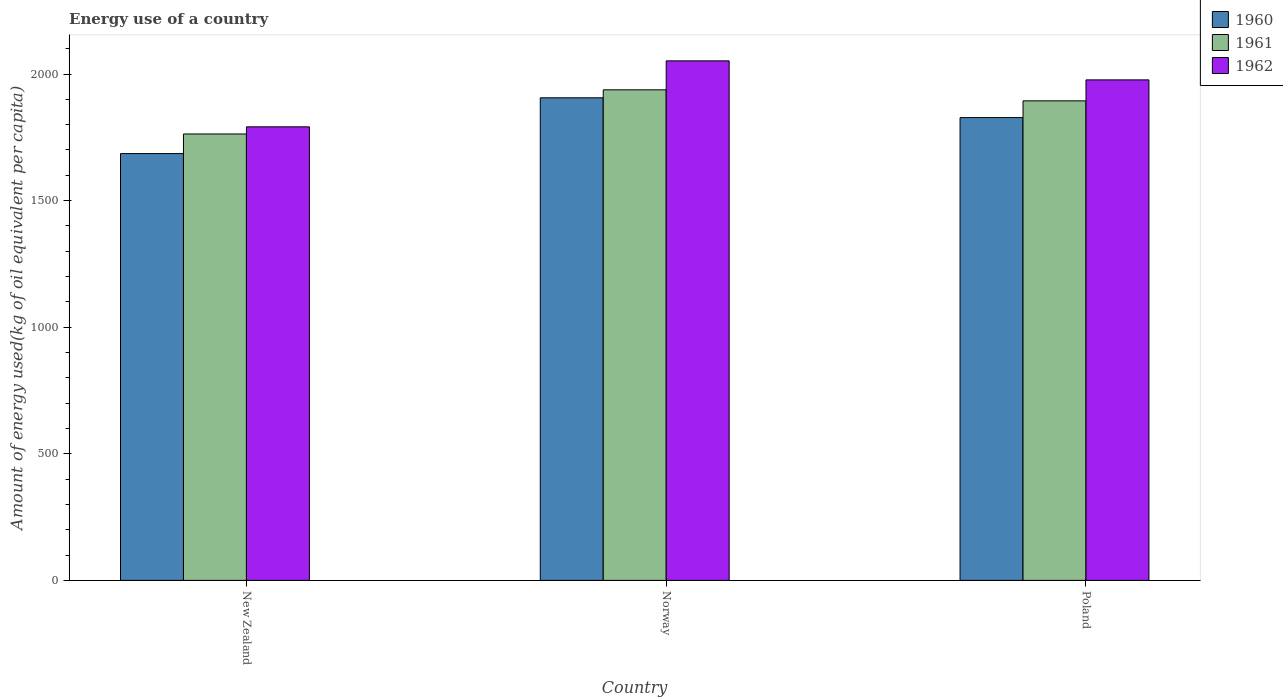How many different coloured bars are there?
Your answer should be compact. 3. Are the number of bars per tick equal to the number of legend labels?
Give a very brief answer. Yes. How many bars are there on the 3rd tick from the left?
Provide a short and direct response. 3. How many bars are there on the 3rd tick from the right?
Offer a very short reply. 3. What is the label of the 3rd group of bars from the left?
Ensure brevity in your answer.  Poland. In how many cases, is the number of bars for a given country not equal to the number of legend labels?
Make the answer very short. 0. What is the amount of energy used in in 1961 in Norway?
Provide a succinct answer. 1937.64. Across all countries, what is the maximum amount of energy used in in 1960?
Your answer should be compact. 1906.17. Across all countries, what is the minimum amount of energy used in in 1960?
Your response must be concise. 1685.79. In which country was the amount of energy used in in 1962 maximum?
Your answer should be compact. Norway. In which country was the amount of energy used in in 1962 minimum?
Offer a terse response. New Zealand. What is the total amount of energy used in in 1960 in the graph?
Offer a very short reply. 5419.9. What is the difference between the amount of energy used in in 1960 in Norway and that in Poland?
Provide a short and direct response. 78.24. What is the difference between the amount of energy used in in 1961 in Norway and the amount of energy used in in 1960 in New Zealand?
Provide a short and direct response. 251.86. What is the average amount of energy used in in 1960 per country?
Ensure brevity in your answer.  1806.63. What is the difference between the amount of energy used in of/in 1962 and amount of energy used in of/in 1961 in Norway?
Your answer should be very brief. 114.41. In how many countries, is the amount of energy used in in 1962 greater than 300 kg?
Your answer should be compact. 3. What is the ratio of the amount of energy used in in 1961 in New Zealand to that in Poland?
Offer a very short reply. 0.93. Is the amount of energy used in in 1962 in New Zealand less than that in Poland?
Ensure brevity in your answer.  Yes. What is the difference between the highest and the second highest amount of energy used in in 1962?
Offer a terse response. -75.19. What is the difference between the highest and the lowest amount of energy used in in 1962?
Give a very brief answer. 260.59. In how many countries, is the amount of energy used in in 1960 greater than the average amount of energy used in in 1960 taken over all countries?
Provide a short and direct response. 2. Is the sum of the amount of energy used in in 1961 in New Zealand and Poland greater than the maximum amount of energy used in in 1960 across all countries?
Provide a short and direct response. Yes. What does the 2nd bar from the right in Poland represents?
Give a very brief answer. 1961. Is it the case that in every country, the sum of the amount of energy used in in 1962 and amount of energy used in in 1960 is greater than the amount of energy used in in 1961?
Provide a succinct answer. Yes. How many bars are there?
Keep it short and to the point. 9. Are the values on the major ticks of Y-axis written in scientific E-notation?
Provide a succinct answer. No. Does the graph contain grids?
Ensure brevity in your answer.  No. How are the legend labels stacked?
Your response must be concise. Vertical. What is the title of the graph?
Provide a short and direct response. Energy use of a country. Does "1992" appear as one of the legend labels in the graph?
Provide a short and direct response. No. What is the label or title of the Y-axis?
Your answer should be compact. Amount of energy used(kg of oil equivalent per capita). What is the Amount of energy used(kg of oil equivalent per capita) of 1960 in New Zealand?
Offer a very short reply. 1685.79. What is the Amount of energy used(kg of oil equivalent per capita) of 1961 in New Zealand?
Your answer should be very brief. 1763.26. What is the Amount of energy used(kg of oil equivalent per capita) of 1962 in New Zealand?
Provide a short and direct response. 1791.46. What is the Amount of energy used(kg of oil equivalent per capita) of 1960 in Norway?
Ensure brevity in your answer.  1906.17. What is the Amount of energy used(kg of oil equivalent per capita) of 1961 in Norway?
Make the answer very short. 1937.64. What is the Amount of energy used(kg of oil equivalent per capita) of 1962 in Norway?
Make the answer very short. 2052.05. What is the Amount of energy used(kg of oil equivalent per capita) in 1960 in Poland?
Provide a short and direct response. 1827.94. What is the Amount of energy used(kg of oil equivalent per capita) in 1961 in Poland?
Provide a succinct answer. 1894.06. What is the Amount of energy used(kg of oil equivalent per capita) in 1962 in Poland?
Provide a short and direct response. 1976.86. Across all countries, what is the maximum Amount of energy used(kg of oil equivalent per capita) of 1960?
Your answer should be very brief. 1906.17. Across all countries, what is the maximum Amount of energy used(kg of oil equivalent per capita) in 1961?
Provide a succinct answer. 1937.64. Across all countries, what is the maximum Amount of energy used(kg of oil equivalent per capita) in 1962?
Give a very brief answer. 2052.05. Across all countries, what is the minimum Amount of energy used(kg of oil equivalent per capita) of 1960?
Your response must be concise. 1685.79. Across all countries, what is the minimum Amount of energy used(kg of oil equivalent per capita) of 1961?
Provide a short and direct response. 1763.26. Across all countries, what is the minimum Amount of energy used(kg of oil equivalent per capita) of 1962?
Offer a terse response. 1791.46. What is the total Amount of energy used(kg of oil equivalent per capita) of 1960 in the graph?
Keep it short and to the point. 5419.9. What is the total Amount of energy used(kg of oil equivalent per capita) in 1961 in the graph?
Ensure brevity in your answer.  5594.96. What is the total Amount of energy used(kg of oil equivalent per capita) in 1962 in the graph?
Your answer should be very brief. 5820.38. What is the difference between the Amount of energy used(kg of oil equivalent per capita) in 1960 in New Zealand and that in Norway?
Your answer should be compact. -220.39. What is the difference between the Amount of energy used(kg of oil equivalent per capita) of 1961 in New Zealand and that in Norway?
Ensure brevity in your answer.  -174.38. What is the difference between the Amount of energy used(kg of oil equivalent per capita) of 1962 in New Zealand and that in Norway?
Your answer should be very brief. -260.59. What is the difference between the Amount of energy used(kg of oil equivalent per capita) in 1960 in New Zealand and that in Poland?
Your answer should be compact. -142.15. What is the difference between the Amount of energy used(kg of oil equivalent per capita) of 1961 in New Zealand and that in Poland?
Provide a succinct answer. -130.8. What is the difference between the Amount of energy used(kg of oil equivalent per capita) of 1962 in New Zealand and that in Poland?
Your response must be concise. -185.4. What is the difference between the Amount of energy used(kg of oil equivalent per capita) in 1960 in Norway and that in Poland?
Make the answer very short. 78.24. What is the difference between the Amount of energy used(kg of oil equivalent per capita) of 1961 in Norway and that in Poland?
Make the answer very short. 43.59. What is the difference between the Amount of energy used(kg of oil equivalent per capita) of 1962 in Norway and that in Poland?
Make the answer very short. 75.19. What is the difference between the Amount of energy used(kg of oil equivalent per capita) of 1960 in New Zealand and the Amount of energy used(kg of oil equivalent per capita) of 1961 in Norway?
Keep it short and to the point. -251.86. What is the difference between the Amount of energy used(kg of oil equivalent per capita) of 1960 in New Zealand and the Amount of energy used(kg of oil equivalent per capita) of 1962 in Norway?
Provide a short and direct response. -366.27. What is the difference between the Amount of energy used(kg of oil equivalent per capita) in 1961 in New Zealand and the Amount of energy used(kg of oil equivalent per capita) in 1962 in Norway?
Offer a terse response. -288.79. What is the difference between the Amount of energy used(kg of oil equivalent per capita) in 1960 in New Zealand and the Amount of energy used(kg of oil equivalent per capita) in 1961 in Poland?
Keep it short and to the point. -208.27. What is the difference between the Amount of energy used(kg of oil equivalent per capita) in 1960 in New Zealand and the Amount of energy used(kg of oil equivalent per capita) in 1962 in Poland?
Your response must be concise. -291.07. What is the difference between the Amount of energy used(kg of oil equivalent per capita) of 1961 in New Zealand and the Amount of energy used(kg of oil equivalent per capita) of 1962 in Poland?
Provide a short and direct response. -213.6. What is the difference between the Amount of energy used(kg of oil equivalent per capita) in 1960 in Norway and the Amount of energy used(kg of oil equivalent per capita) in 1961 in Poland?
Offer a very short reply. 12.12. What is the difference between the Amount of energy used(kg of oil equivalent per capita) in 1960 in Norway and the Amount of energy used(kg of oil equivalent per capita) in 1962 in Poland?
Offer a terse response. -70.68. What is the difference between the Amount of energy used(kg of oil equivalent per capita) of 1961 in Norway and the Amount of energy used(kg of oil equivalent per capita) of 1962 in Poland?
Ensure brevity in your answer.  -39.22. What is the average Amount of energy used(kg of oil equivalent per capita) of 1960 per country?
Keep it short and to the point. 1806.63. What is the average Amount of energy used(kg of oil equivalent per capita) of 1961 per country?
Offer a very short reply. 1864.99. What is the average Amount of energy used(kg of oil equivalent per capita) in 1962 per country?
Give a very brief answer. 1940.13. What is the difference between the Amount of energy used(kg of oil equivalent per capita) in 1960 and Amount of energy used(kg of oil equivalent per capita) in 1961 in New Zealand?
Give a very brief answer. -77.47. What is the difference between the Amount of energy used(kg of oil equivalent per capita) in 1960 and Amount of energy used(kg of oil equivalent per capita) in 1962 in New Zealand?
Provide a succinct answer. -105.67. What is the difference between the Amount of energy used(kg of oil equivalent per capita) of 1961 and Amount of energy used(kg of oil equivalent per capita) of 1962 in New Zealand?
Make the answer very short. -28.2. What is the difference between the Amount of energy used(kg of oil equivalent per capita) of 1960 and Amount of energy used(kg of oil equivalent per capita) of 1961 in Norway?
Your response must be concise. -31.47. What is the difference between the Amount of energy used(kg of oil equivalent per capita) of 1960 and Amount of energy used(kg of oil equivalent per capita) of 1962 in Norway?
Ensure brevity in your answer.  -145.88. What is the difference between the Amount of energy used(kg of oil equivalent per capita) in 1961 and Amount of energy used(kg of oil equivalent per capita) in 1962 in Norway?
Provide a succinct answer. -114.41. What is the difference between the Amount of energy used(kg of oil equivalent per capita) of 1960 and Amount of energy used(kg of oil equivalent per capita) of 1961 in Poland?
Your answer should be compact. -66.12. What is the difference between the Amount of energy used(kg of oil equivalent per capita) in 1960 and Amount of energy used(kg of oil equivalent per capita) in 1962 in Poland?
Your answer should be compact. -148.92. What is the difference between the Amount of energy used(kg of oil equivalent per capita) in 1961 and Amount of energy used(kg of oil equivalent per capita) in 1962 in Poland?
Offer a very short reply. -82.8. What is the ratio of the Amount of energy used(kg of oil equivalent per capita) of 1960 in New Zealand to that in Norway?
Your response must be concise. 0.88. What is the ratio of the Amount of energy used(kg of oil equivalent per capita) of 1961 in New Zealand to that in Norway?
Provide a succinct answer. 0.91. What is the ratio of the Amount of energy used(kg of oil equivalent per capita) in 1962 in New Zealand to that in Norway?
Your answer should be compact. 0.87. What is the ratio of the Amount of energy used(kg of oil equivalent per capita) in 1960 in New Zealand to that in Poland?
Your answer should be very brief. 0.92. What is the ratio of the Amount of energy used(kg of oil equivalent per capita) in 1961 in New Zealand to that in Poland?
Make the answer very short. 0.93. What is the ratio of the Amount of energy used(kg of oil equivalent per capita) in 1962 in New Zealand to that in Poland?
Provide a short and direct response. 0.91. What is the ratio of the Amount of energy used(kg of oil equivalent per capita) in 1960 in Norway to that in Poland?
Your answer should be very brief. 1.04. What is the ratio of the Amount of energy used(kg of oil equivalent per capita) in 1962 in Norway to that in Poland?
Provide a succinct answer. 1.04. What is the difference between the highest and the second highest Amount of energy used(kg of oil equivalent per capita) in 1960?
Offer a terse response. 78.24. What is the difference between the highest and the second highest Amount of energy used(kg of oil equivalent per capita) of 1961?
Keep it short and to the point. 43.59. What is the difference between the highest and the second highest Amount of energy used(kg of oil equivalent per capita) of 1962?
Give a very brief answer. 75.19. What is the difference between the highest and the lowest Amount of energy used(kg of oil equivalent per capita) in 1960?
Give a very brief answer. 220.39. What is the difference between the highest and the lowest Amount of energy used(kg of oil equivalent per capita) in 1961?
Keep it short and to the point. 174.38. What is the difference between the highest and the lowest Amount of energy used(kg of oil equivalent per capita) in 1962?
Offer a very short reply. 260.59. 